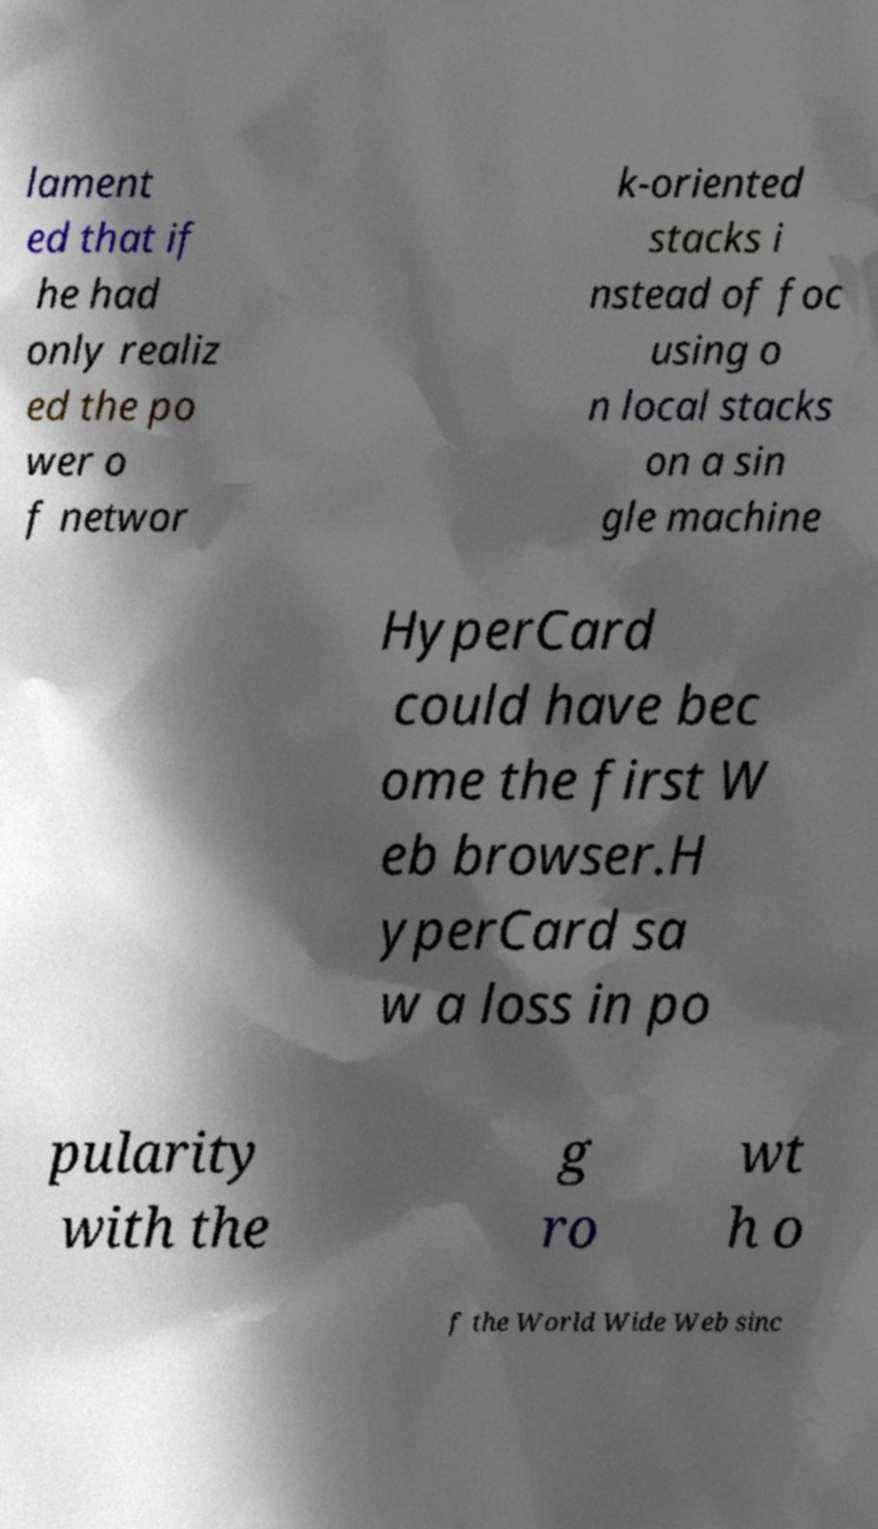There's text embedded in this image that I need extracted. Can you transcribe it verbatim? lament ed that if he had only realiz ed the po wer o f networ k-oriented stacks i nstead of foc using o n local stacks on a sin gle machine HyperCard could have bec ome the first W eb browser.H yperCard sa w a loss in po pularity with the g ro wt h o f the World Wide Web sinc 